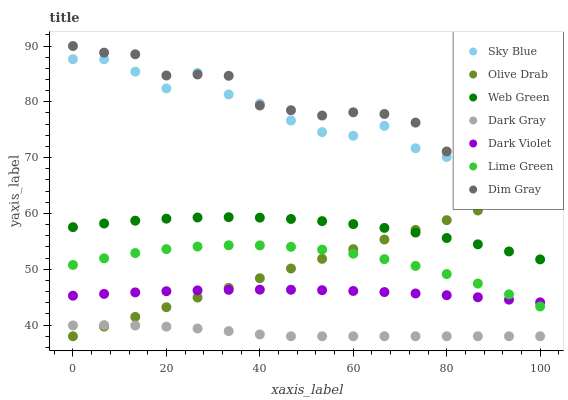Does Dark Gray have the minimum area under the curve?
Answer yes or no. Yes. Does Dim Gray have the maximum area under the curve?
Answer yes or no. Yes. Does Dark Violet have the minimum area under the curve?
Answer yes or no. No. Does Dark Violet have the maximum area under the curve?
Answer yes or no. No. Is Olive Drab the smoothest?
Answer yes or no. Yes. Is Sky Blue the roughest?
Answer yes or no. Yes. Is Dark Violet the smoothest?
Answer yes or no. No. Is Dark Violet the roughest?
Answer yes or no. No. Does Dark Gray have the lowest value?
Answer yes or no. Yes. Does Dark Violet have the lowest value?
Answer yes or no. No. Does Dim Gray have the highest value?
Answer yes or no. Yes. Does Dark Violet have the highest value?
Answer yes or no. No. Is Dark Gray less than Sky Blue?
Answer yes or no. Yes. Is Dim Gray greater than Web Green?
Answer yes or no. Yes. Does Dark Violet intersect Lime Green?
Answer yes or no. Yes. Is Dark Violet less than Lime Green?
Answer yes or no. No. Is Dark Violet greater than Lime Green?
Answer yes or no. No. Does Dark Gray intersect Sky Blue?
Answer yes or no. No. 